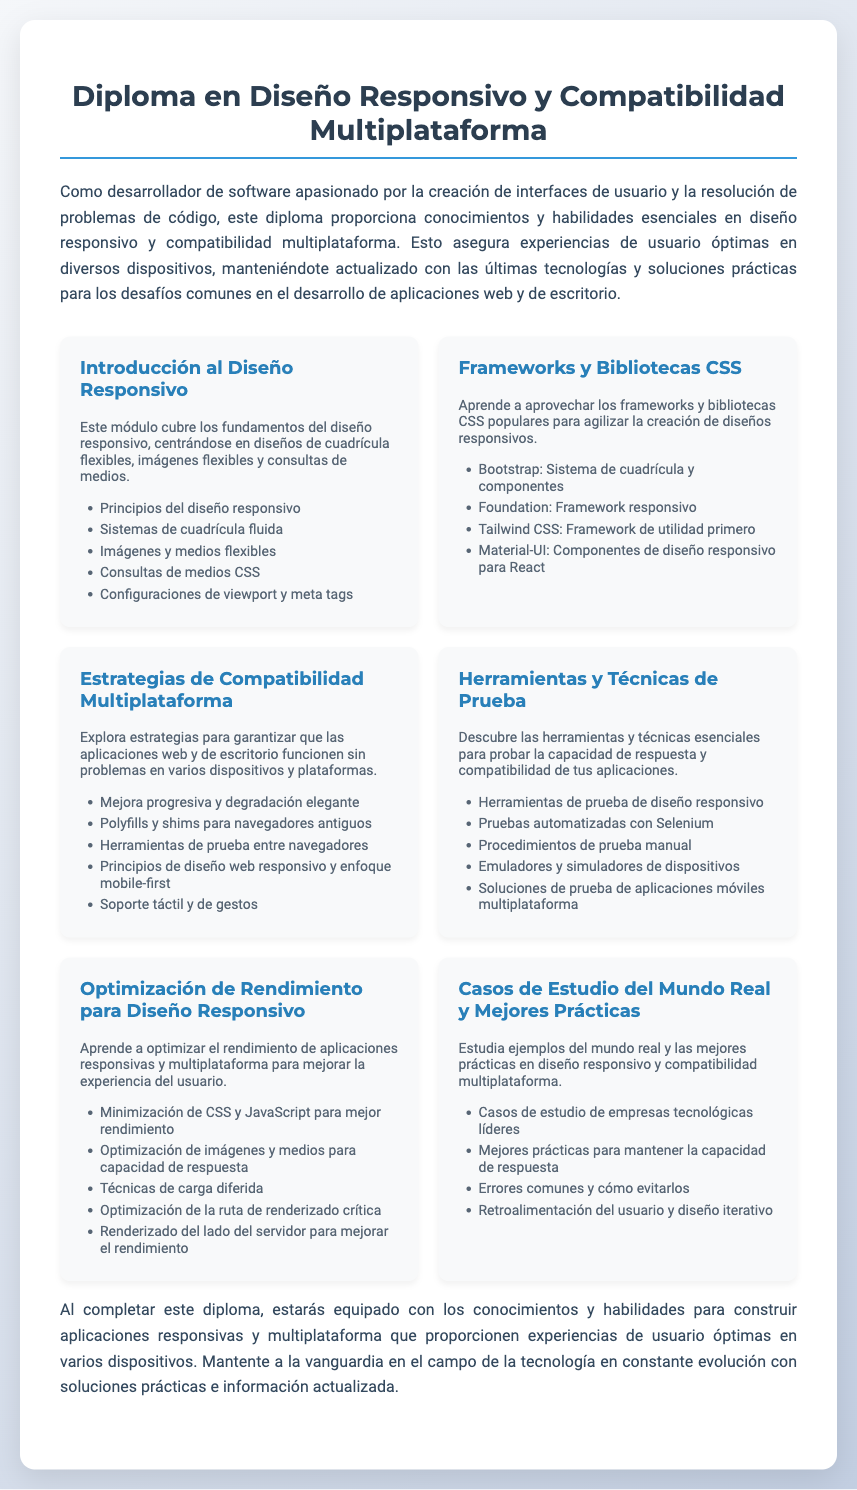¿Qué cubre el módulo "Introducción al Diseño Responsivo"? Este módulo cubre los fundamentos del diseño responsivo, centrándose en diseños de cuadrícula flexibles, imágenes flexibles y consultas de medios.
Answer: Fundamentos del diseño responsivo ¿Cuál es un ejemplo de framework CSS mencionado en el diploma? Se mencionan varios ejemplos de frameworks CSS en el documento, uno de los más populares es Bootstrap.
Answer: Bootstrap ¿Cuántos módulos componen el diploma? Hay un número total de módulos listados en el documento que cubren diversos aspectos del diseño responsivo y la compatibilidad multiplataforma.
Answer: Seis ¿Qué estrategia se menciona para garantizar aplicaciones que funcionen en múltiples plataformas? La estrategia que se menciona para asegurar la funcionalidad en diferentes plataformas es la mejora progresiva y degradación elegante.
Answer: Mejora progresiva y degradación elegante ¿Cuál es el objetivo de estudiar "Casos de Estudio del Mundo Real y Mejores Prácticas"? Este módulo busca ejemplificar mejores prácticas y errores comunes en diseño responsivo y compatibilidad multiplataforma basándose en experiencias reales.
Answer: Ejemplificar mejores prácticas y errores comunes 